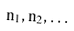Convert formula to latex. <formula><loc_0><loc_0><loc_500><loc_500>n _ { 1 } , n _ { 2 } , \dots</formula> 